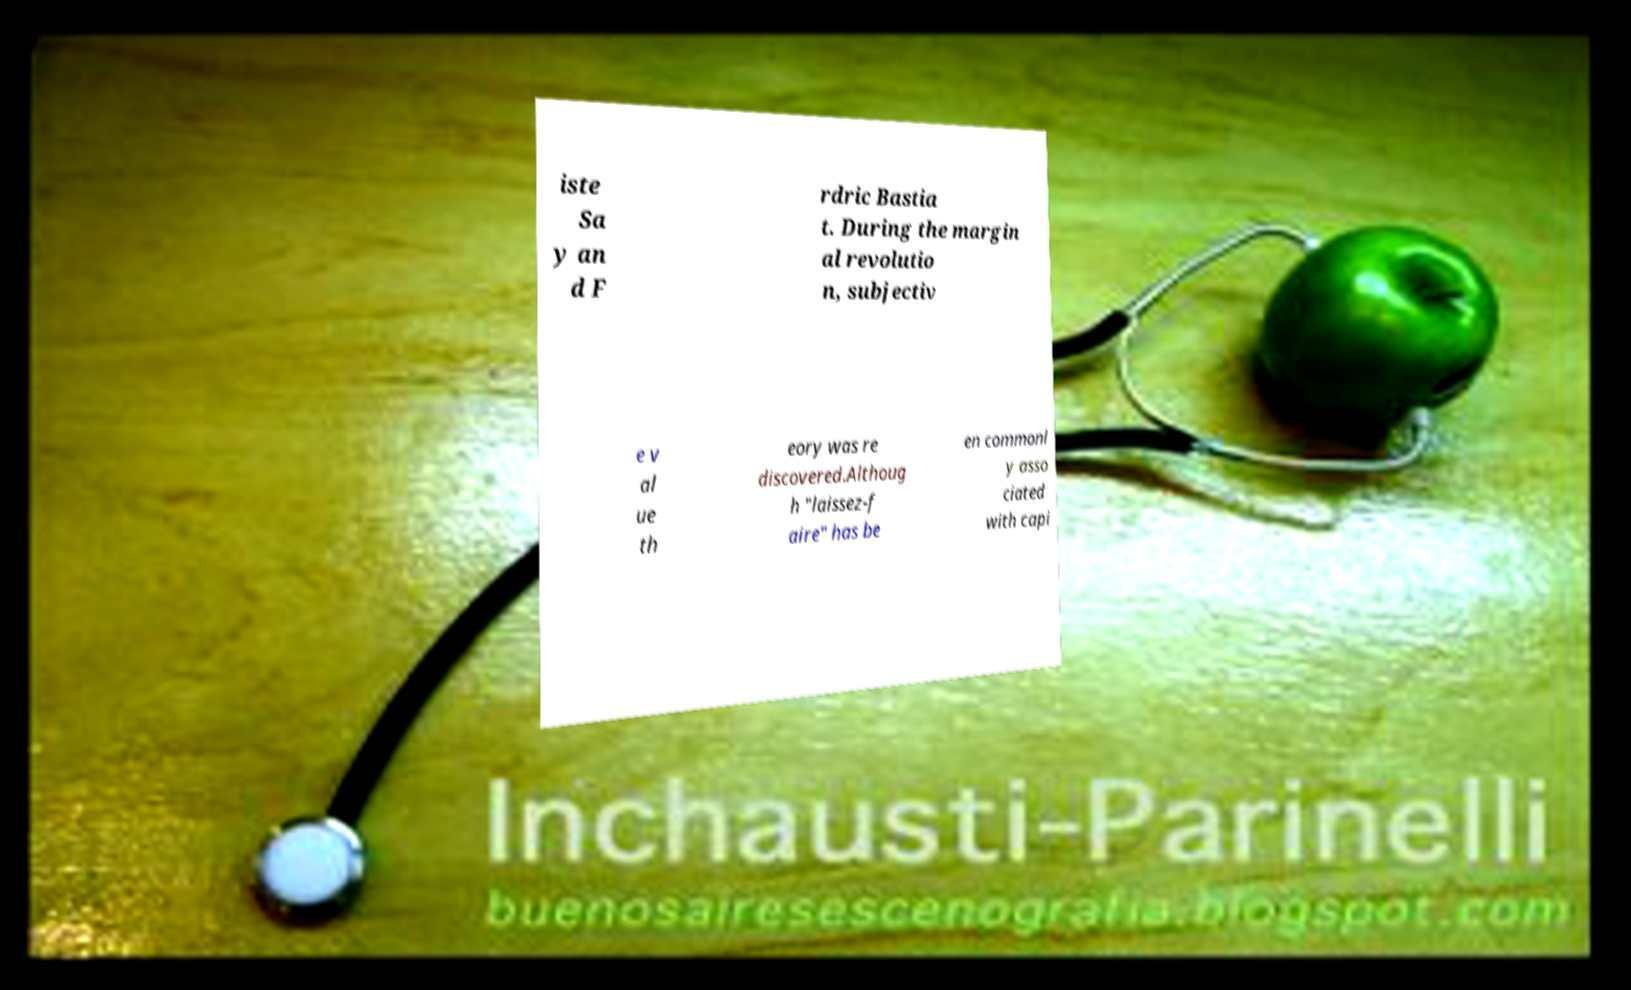What messages or text are displayed in this image? I need them in a readable, typed format. iste Sa y an d F rdric Bastia t. During the margin al revolutio n, subjectiv e v al ue th eory was re discovered.Althoug h "laissez-f aire" has be en commonl y asso ciated with capi 